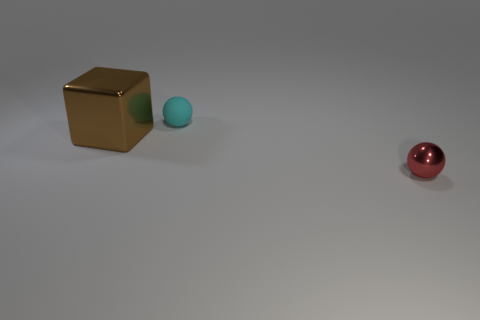What number of objects are either yellow rubber objects or big brown cubes that are to the left of the cyan matte ball?
Offer a very short reply. 1. The red shiny thing that is the same size as the cyan matte object is what shape?
Make the answer very short. Sphere. Does the small object behind the tiny red shiny ball have the same material as the large brown object?
Your answer should be very brief. No. The rubber object is what shape?
Your answer should be very brief. Sphere. What number of cyan things are shiny balls or large metallic things?
Your answer should be compact. 0. What number of other objects are there of the same material as the brown block?
Your response must be concise. 1. Does the tiny thing on the left side of the red metal object have the same shape as the tiny shiny object?
Offer a terse response. Yes. Are there any large red blocks?
Provide a short and direct response. No. Is there anything else that has the same shape as the red object?
Offer a very short reply. Yes. Are there more large things on the left side of the small red ball than big matte spheres?
Give a very brief answer. Yes. 